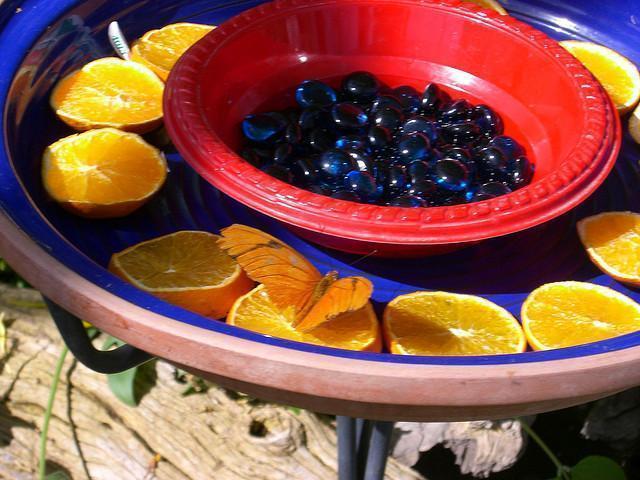What color are the beads inside of the red bowl?
Pick the right solution, then justify: 'Answer: answer
Rationale: rationale.'
Options: Blue, orange, green, red. Answer: blue.
Rationale: The beads in the bowl are this color. 